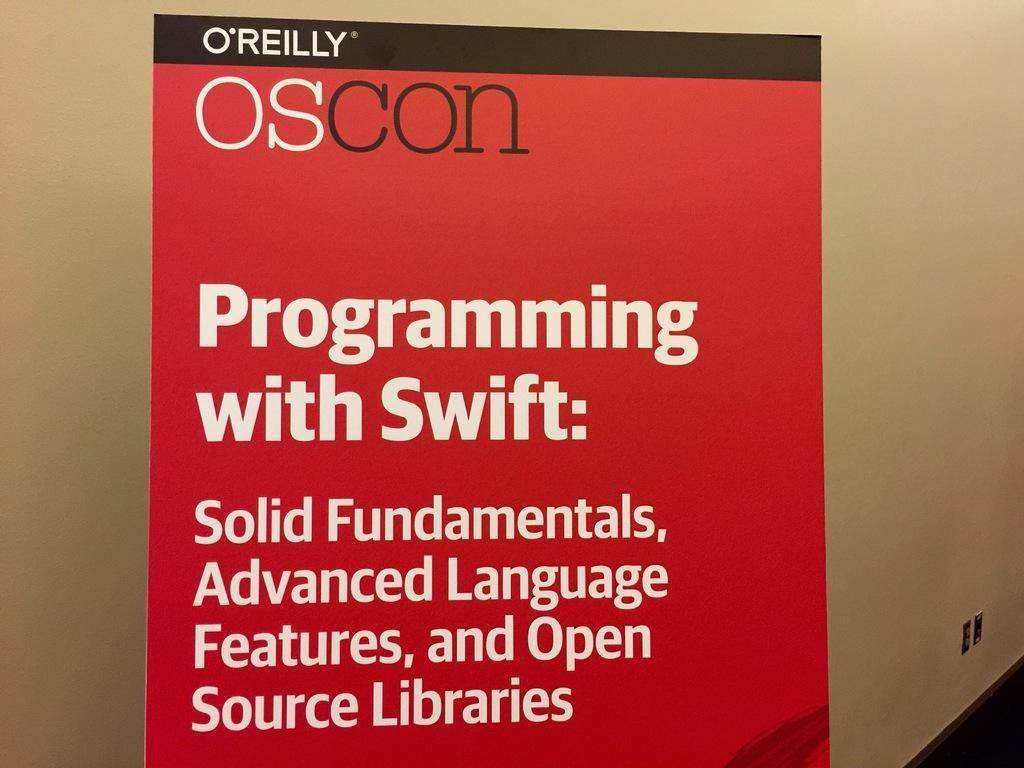<image>
Relay a brief, clear account of the picture shown. A red book cover titled Programming with Swift. 